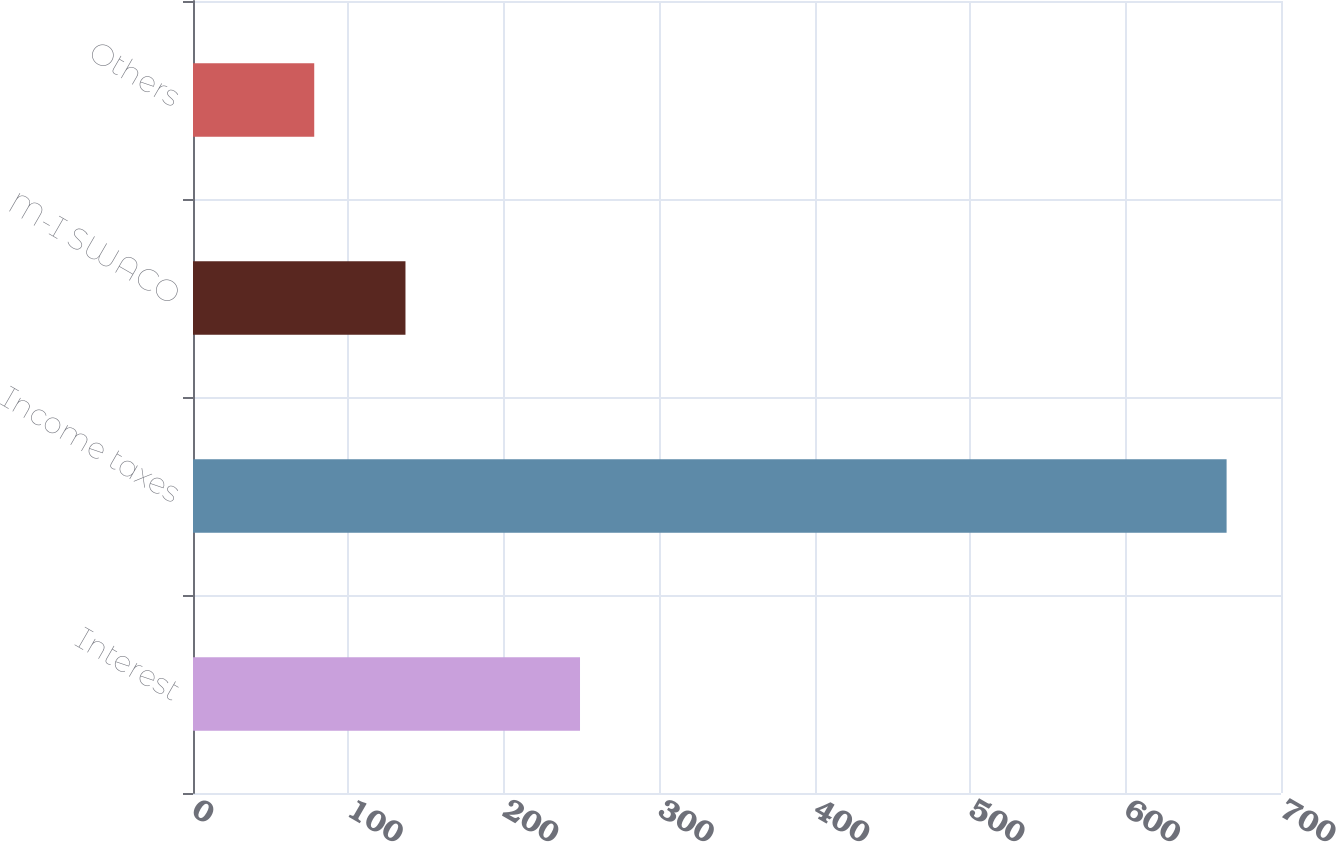<chart> <loc_0><loc_0><loc_500><loc_500><bar_chart><fcel>Interest<fcel>Income taxes<fcel>M-I SWACO<fcel>Others<nl><fcel>249<fcel>665<fcel>136.7<fcel>78<nl></chart> 